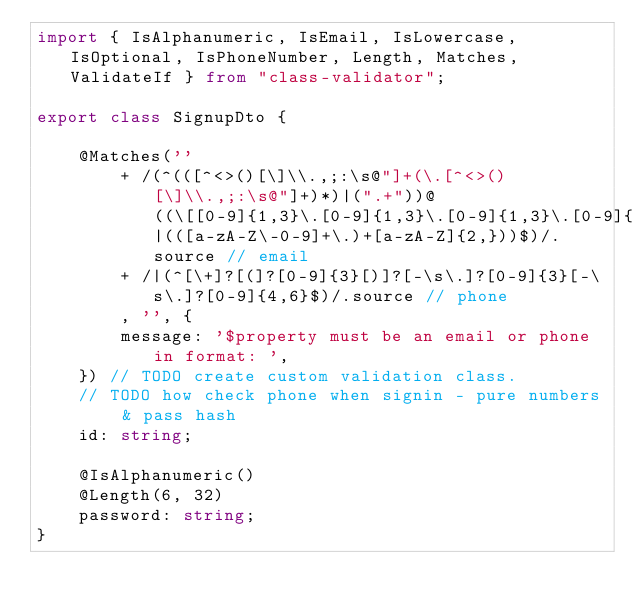Convert code to text. <code><loc_0><loc_0><loc_500><loc_500><_TypeScript_>import { IsAlphanumeric, IsEmail, IsLowercase, IsOptional, IsPhoneNumber, Length, Matches, ValidateIf } from "class-validator";

export class SignupDto {

    @Matches(''
        + /(^(([^<>()[\]\\.,;:\s@"]+(\.[^<>()[\]\\.,;:\s@"]+)*)|(".+"))@((\[[0-9]{1,3}\.[0-9]{1,3}\.[0-9]{1,3}\.[0-9]{1,3}\])|(([a-zA-Z\-0-9]+\.)+[a-zA-Z]{2,}))$)/.source // email
        + /|(^[\+]?[(]?[0-9]{3}[)]?[-\s\.]?[0-9]{3}[-\s\.]?[0-9]{4,6}$)/.source // phone
        , '', {
        message: '$property must be an email or phone in format: ',
    }) // TODO create custom validation class. 
    // TODO how check phone when signin - pure numbers & pass hash
    id: string;

    @IsAlphanumeric()
    @Length(6, 32)
    password: string;
}</code> 